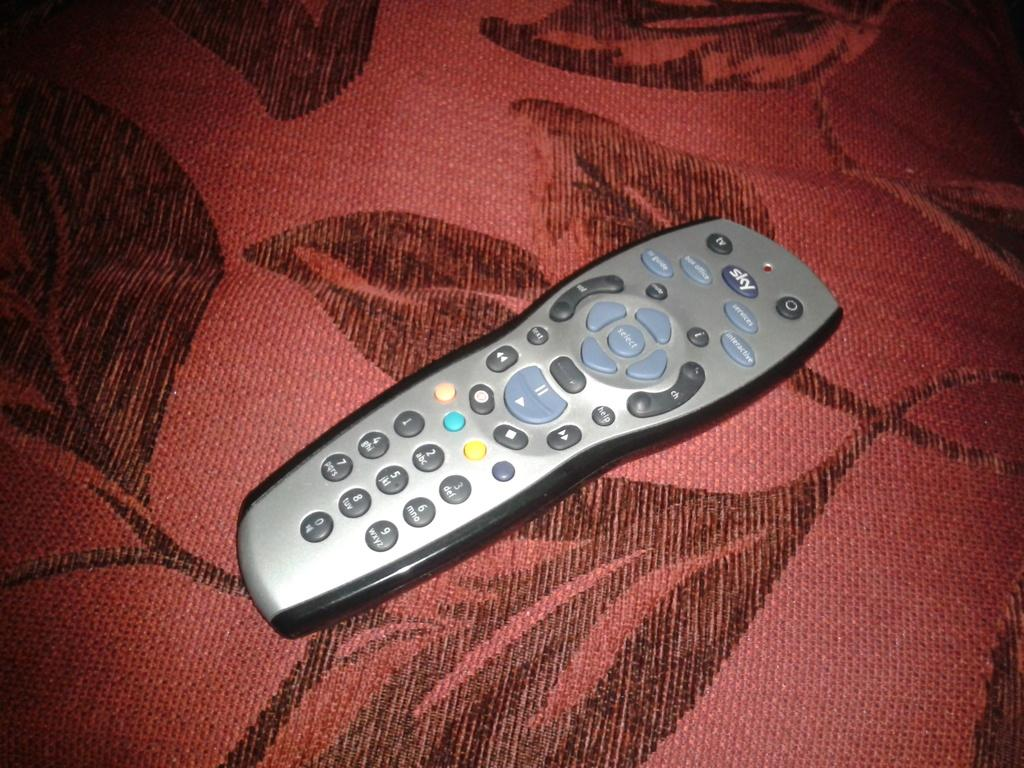<image>
Create a compact narrative representing the image presented. Sky remote in silver and gray seated on rose and brown left material. 